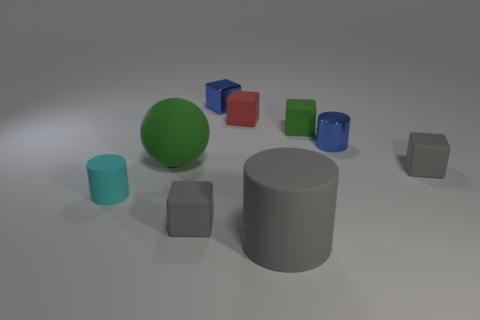There is a metallic cube that is on the left side of the red object; is it the same size as the big cylinder?
Your answer should be very brief. No. What number of matte things are either large red objects or cylinders?
Make the answer very short. 2. There is a tiny cube that is both in front of the metallic block and behind the tiny green rubber thing; what is its material?
Provide a short and direct response. Rubber. Does the ball have the same material as the blue block?
Offer a very short reply. No. What is the size of the object that is both left of the small blue block and on the right side of the green ball?
Offer a terse response. Small. What shape is the tiny cyan rubber object?
Ensure brevity in your answer.  Cylinder. How many things are either small cyan cylinders or blue metallic objects that are left of the small green rubber thing?
Provide a succinct answer. 2. There is a small block behind the small red thing; is its color the same as the small shiny cylinder?
Your answer should be very brief. Yes. What color is the small cube that is both to the left of the tiny blue cylinder and in front of the tiny green rubber block?
Keep it short and to the point. Gray. There is a cyan object on the left side of the tiny red cube; what is it made of?
Give a very brief answer. Rubber. 